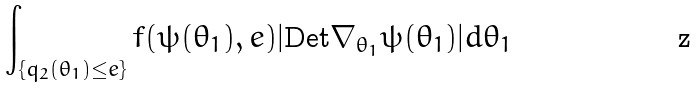<formula> <loc_0><loc_0><loc_500><loc_500>\int _ { \{ q _ { 2 } ( \theta _ { 1 } ) \leq e \} } f ( \psi ( \theta _ { 1 } ) , e ) | \text {Det} \nabla _ { \theta _ { 1 } } \psi ( \theta _ { 1 } ) | d \theta _ { 1 }</formula> 